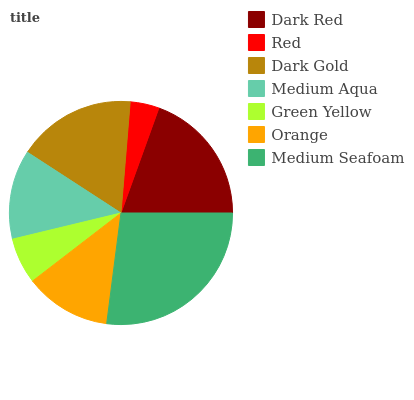Is Red the minimum?
Answer yes or no. Yes. Is Medium Seafoam the maximum?
Answer yes or no. Yes. Is Dark Gold the minimum?
Answer yes or no. No. Is Dark Gold the maximum?
Answer yes or no. No. Is Dark Gold greater than Red?
Answer yes or no. Yes. Is Red less than Dark Gold?
Answer yes or no. Yes. Is Red greater than Dark Gold?
Answer yes or no. No. Is Dark Gold less than Red?
Answer yes or no. No. Is Medium Aqua the high median?
Answer yes or no. Yes. Is Medium Aqua the low median?
Answer yes or no. Yes. Is Dark Red the high median?
Answer yes or no. No. Is Medium Seafoam the low median?
Answer yes or no. No. 